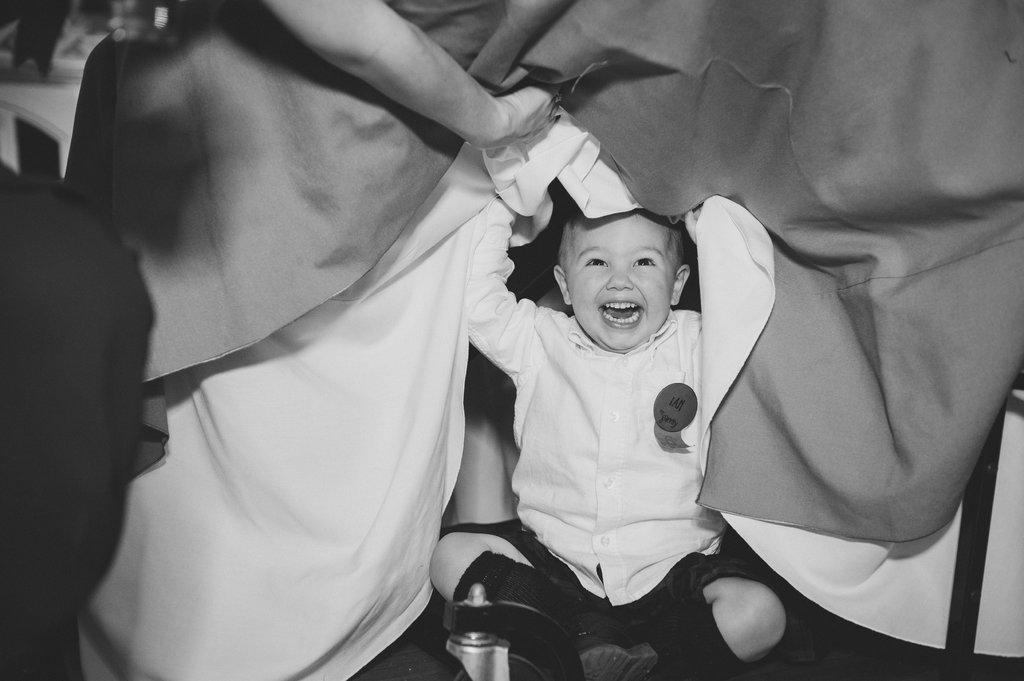What is the child doing in the image? The child is sitting and laughing in the image. What is the child holding in the image? The child is holding a blanket in the image. What else can be seen in the image besides the child? There is a water bottle in the image. Whose hand is holding a blanket in the image? A person's hand is holding a blanket in the image. Is the child using a rake to gather leaves in the image? No, there is no rake present in the image, and the child is not gathering leaves. 